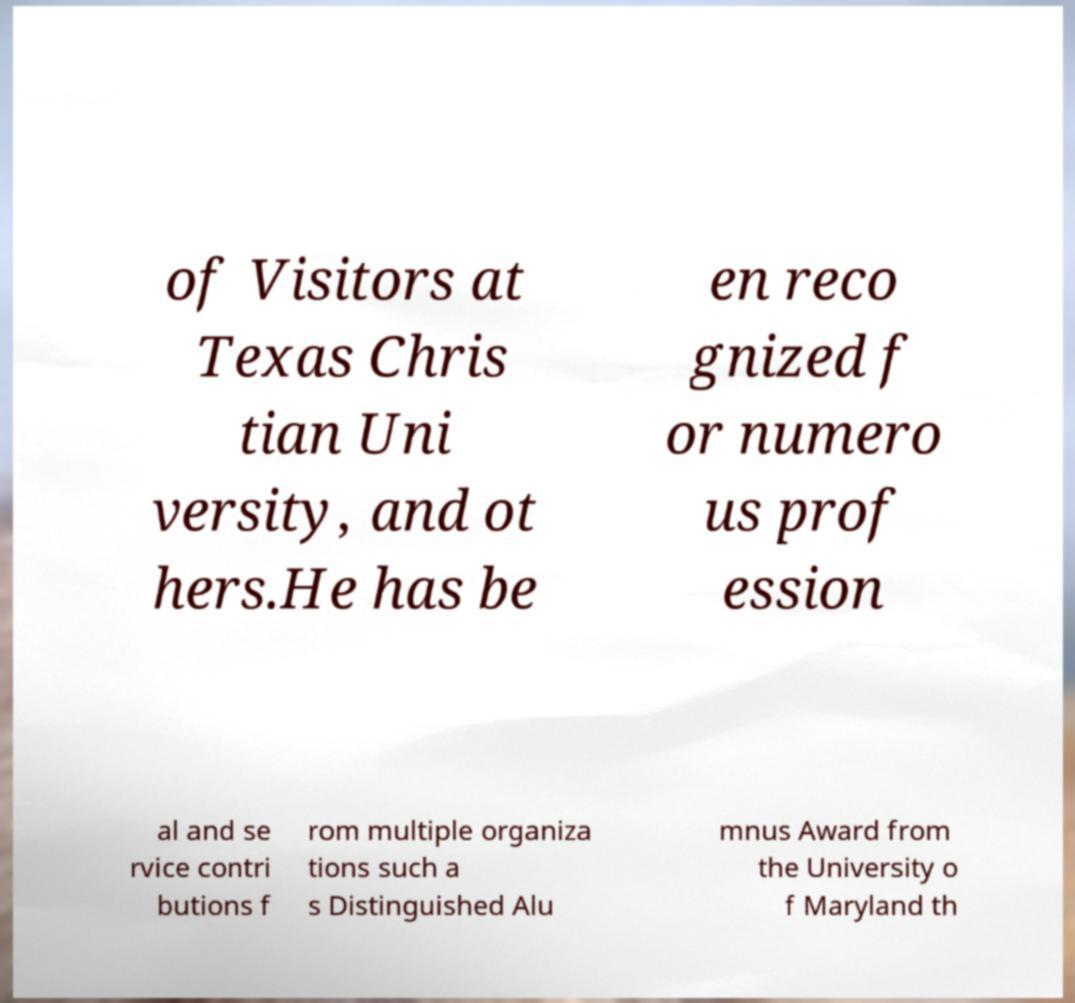Please read and relay the text visible in this image. What does it say? of Visitors at Texas Chris tian Uni versity, and ot hers.He has be en reco gnized f or numero us prof ession al and se rvice contri butions f rom multiple organiza tions such a s Distinguished Alu mnus Award from the University o f Maryland th 